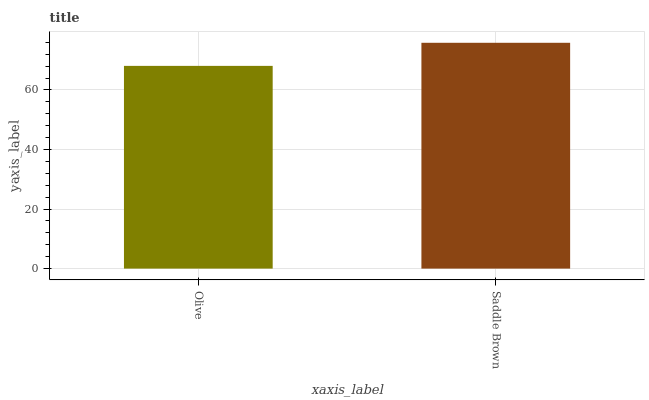Is Olive the minimum?
Answer yes or no. Yes. Is Saddle Brown the maximum?
Answer yes or no. Yes. Is Saddle Brown the minimum?
Answer yes or no. No. Is Saddle Brown greater than Olive?
Answer yes or no. Yes. Is Olive less than Saddle Brown?
Answer yes or no. Yes. Is Olive greater than Saddle Brown?
Answer yes or no. No. Is Saddle Brown less than Olive?
Answer yes or no. No. Is Saddle Brown the high median?
Answer yes or no. Yes. Is Olive the low median?
Answer yes or no. Yes. Is Olive the high median?
Answer yes or no. No. Is Saddle Brown the low median?
Answer yes or no. No. 